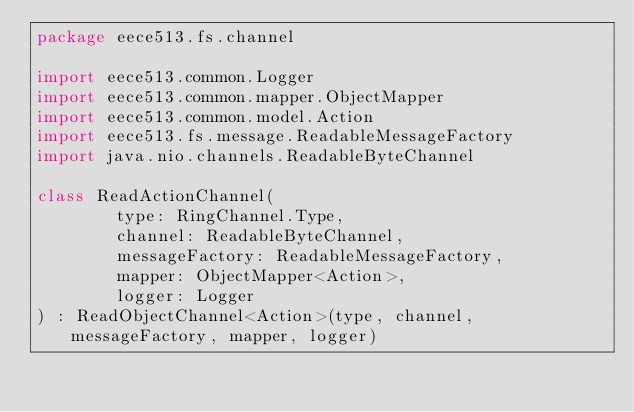<code> <loc_0><loc_0><loc_500><loc_500><_Kotlin_>package eece513.fs.channel

import eece513.common.Logger
import eece513.common.mapper.ObjectMapper
import eece513.common.model.Action
import eece513.fs.message.ReadableMessageFactory
import java.nio.channels.ReadableByteChannel

class ReadActionChannel(
        type: RingChannel.Type,
        channel: ReadableByteChannel,
        messageFactory: ReadableMessageFactory,
        mapper: ObjectMapper<Action>,
        logger: Logger
) : ReadObjectChannel<Action>(type, channel, messageFactory, mapper, logger)</code> 